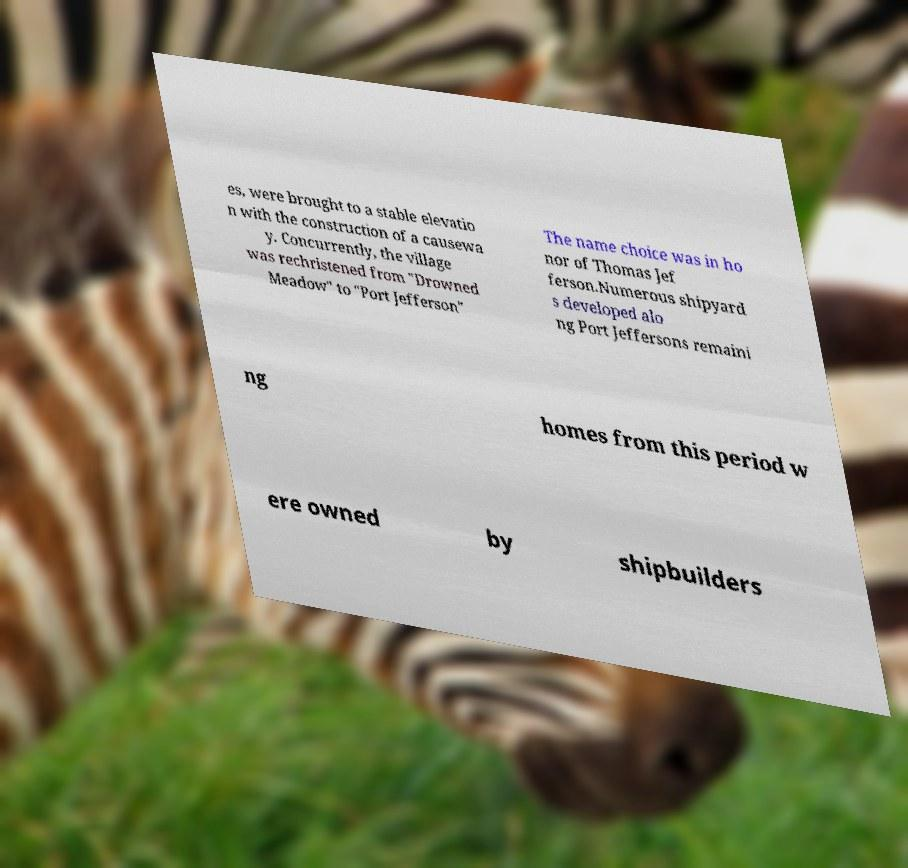Please identify and transcribe the text found in this image. es, were brought to a stable elevatio n with the construction of a causewa y. Concurrently, the village was rechristened from "Drowned Meadow" to "Port Jefferson" The name choice was in ho nor of Thomas Jef ferson.Numerous shipyard s developed alo ng Port Jeffersons remaini ng homes from this period w ere owned by shipbuilders 